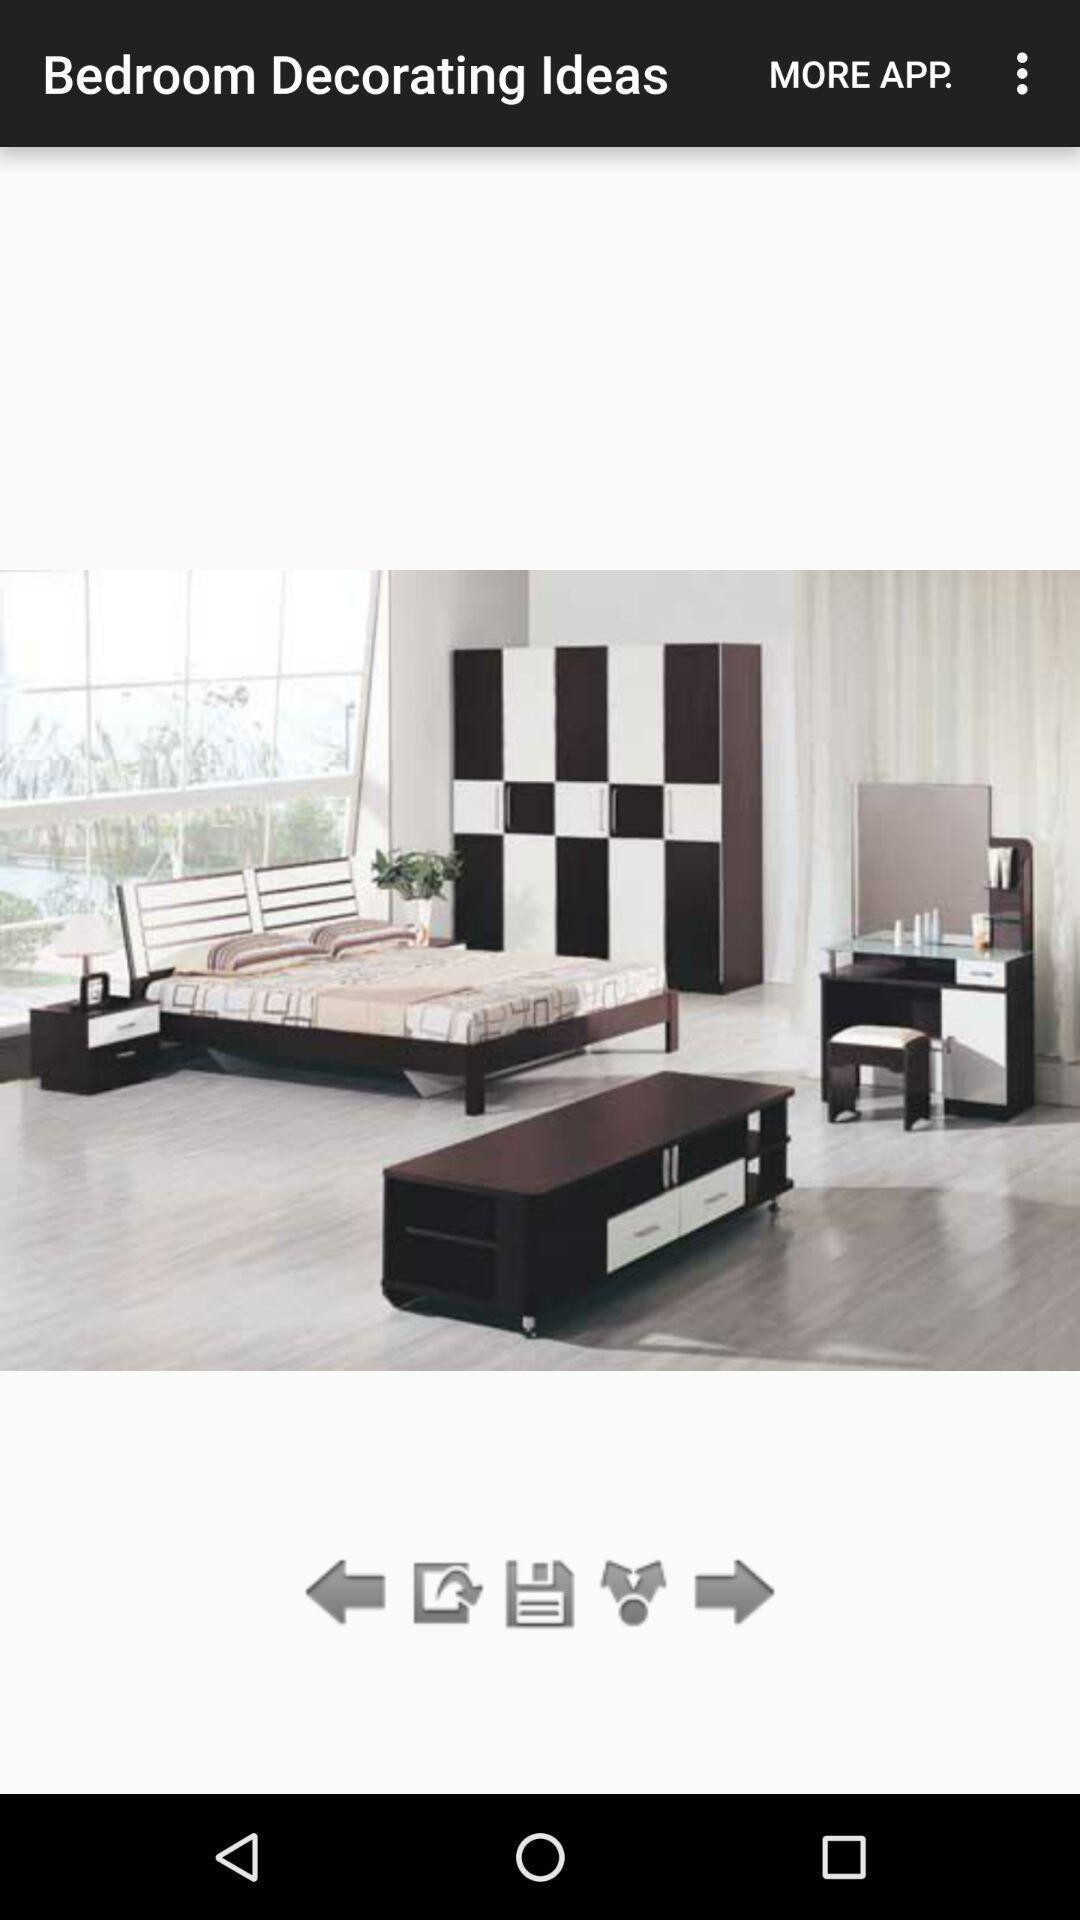Summarize the information in this screenshot. Page showing image. 